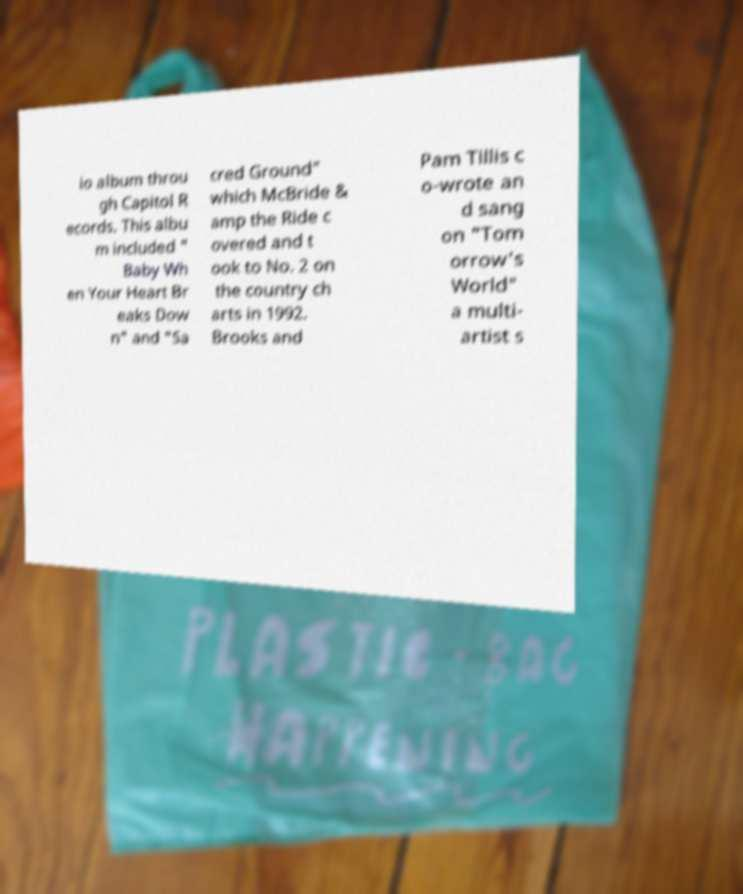For documentation purposes, I need the text within this image transcribed. Could you provide that? io album throu gh Capitol R ecords. This albu m included " Baby Wh en Your Heart Br eaks Dow n" and "Sa cred Ground" which McBride & amp the Ride c overed and t ook to No. 2 on the country ch arts in 1992. Brooks and Pam Tillis c o-wrote an d sang on "Tom orrow's World" a multi- artist s 